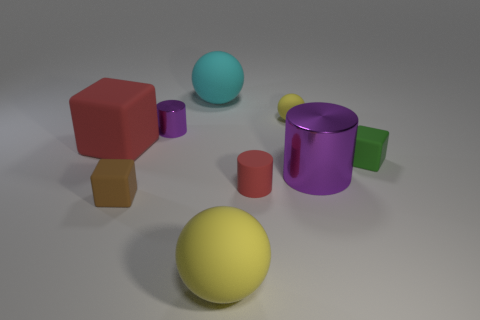What colors are the objects in the image? The objects in the image are red, yellow, green, purple, blue, and brown. 